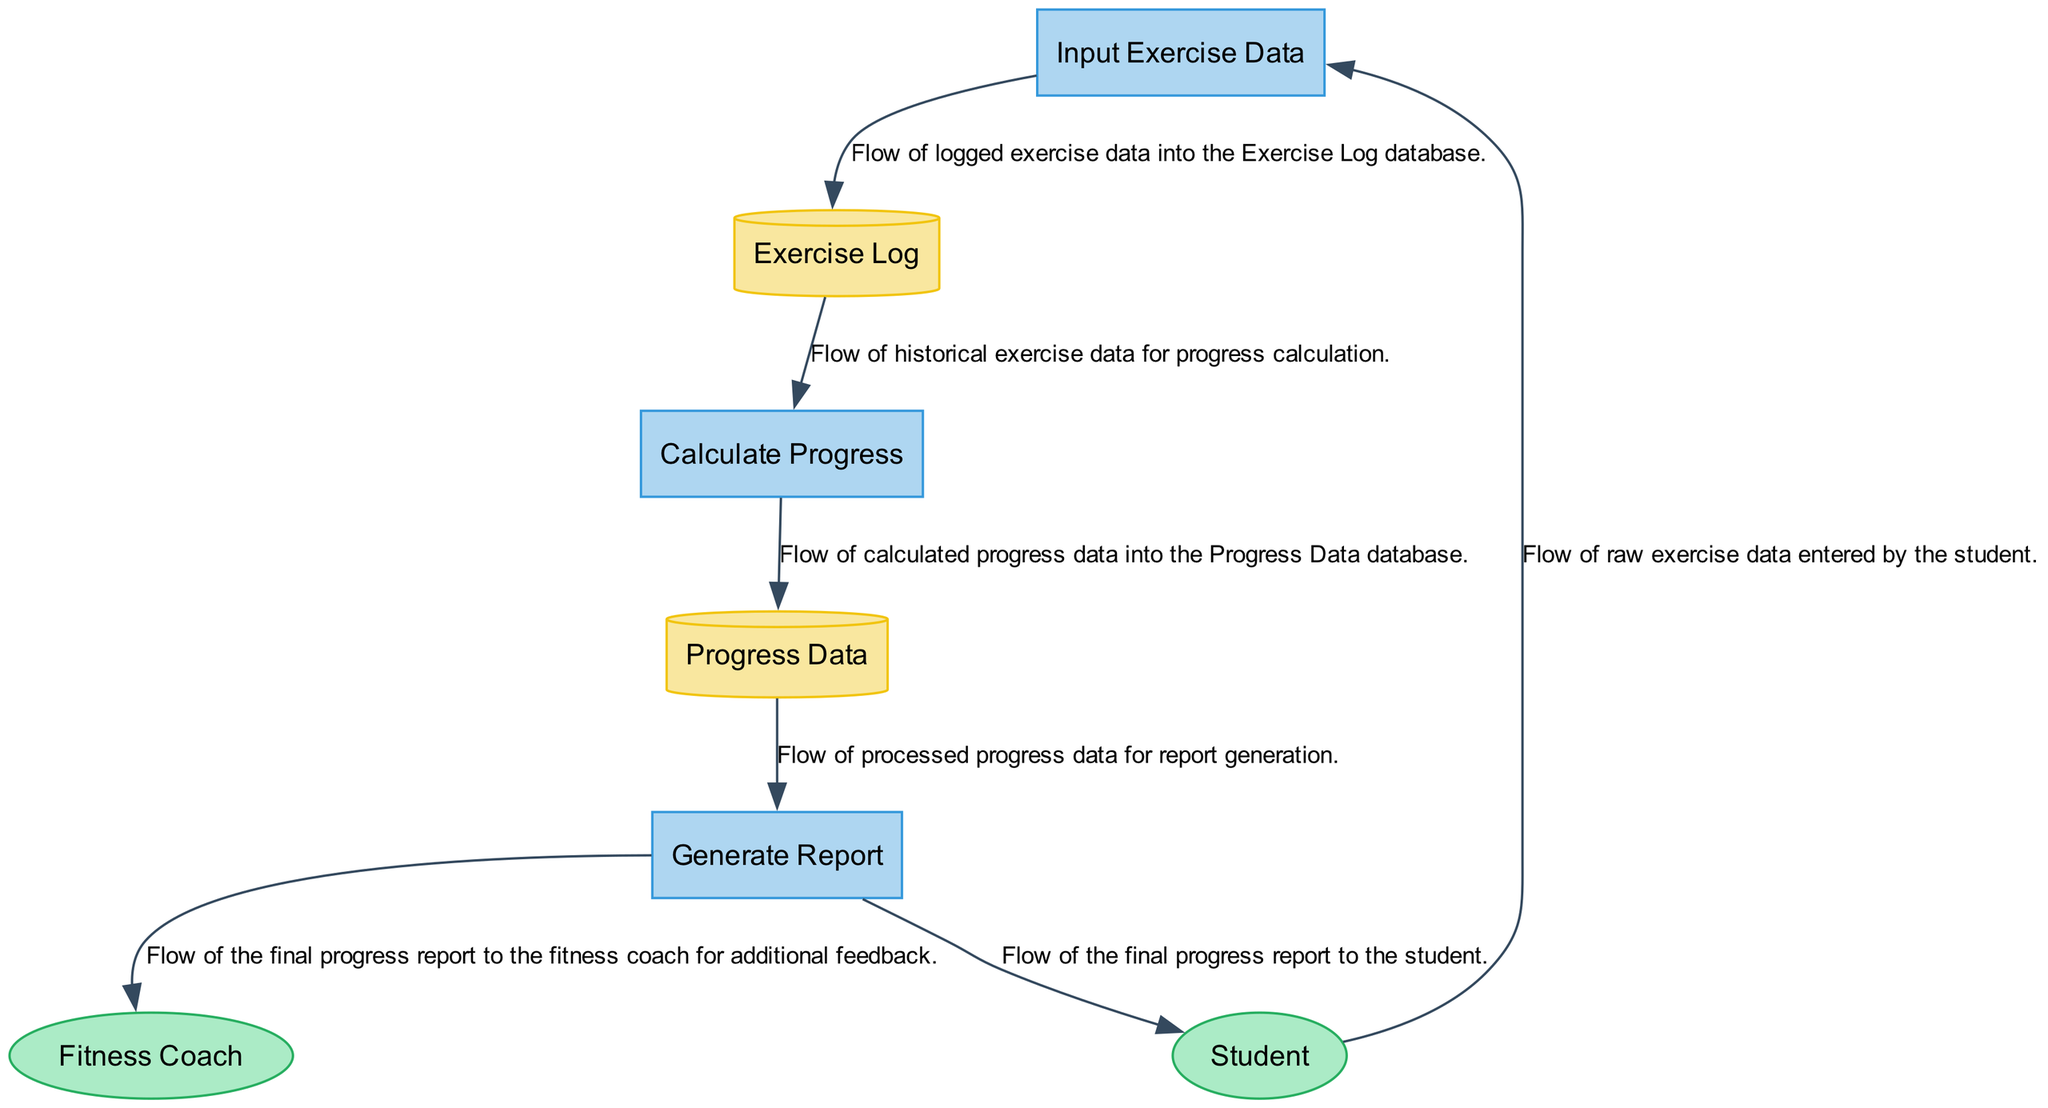What is the first process in the diagram? The first process listed in the diagram is "Input Exercise Data." This can be identified by looking for processes in the diagram, specifically the one that corresponds to the ID 1.
Answer: Input Exercise Data How many external entities are represented in the diagram? The diagram features two external entities. By counting the nodes labeled as external entities, we can confirm that there are two: "Student" and "Fitness Coach."
Answer: 2 What type of data is stored in the Exercise Log? The Exercise Log stores logged exercise data, which includes records of exercises entered by the student like duration, type, and intensity. This can be derived from the description of the Exercise Log data store.
Answer: Logged exercise data Which process generates a report? The "Generate Report" process is responsible for producing the report. This process can be identified with the specific name given in the diagram.
Answer: Generate Report What data flow originates from the Calculate Progress process? The data flow that originates from the Calculate Progress process is directed to the Progress Data database. This is evident from the data flow line in the diagram leading to the Progress Data, as indicated in the description.
Answer: Progress Data What is the flow of information from the Student to the Input Exercise Data process? The flow of information from the Student to the Input Exercise Data process consists of raw exercise data entered by the student. This is explicitly stated in the data flow description connecting them.
Answer: Raw exercise data How does the Generate Report process receive data? The Generate Report process receives processed progress data, which is drawn from the Progress Data database. This can be tracked step by step from the flow leading from the Progress Data to the Generate Report process.
Answer: Processed progress data What is the purpose of the Fitness Coach external entity? The Fitness Coach serves to provide feedback and monitor the student's progress. This is described in the Fitness Coach's description as an optional external entity within the diagram's data.
Answer: Provide feedback and monitor progress What connects the Input Exercise Data to the Exercise Log? The connection between Input Exercise Data and the Exercise Log is made through a data flow that logs the exercise data into the Exercise Log. This is explicitly conveyed in the data flow description linking these two points.
Answer: Logged exercise data 